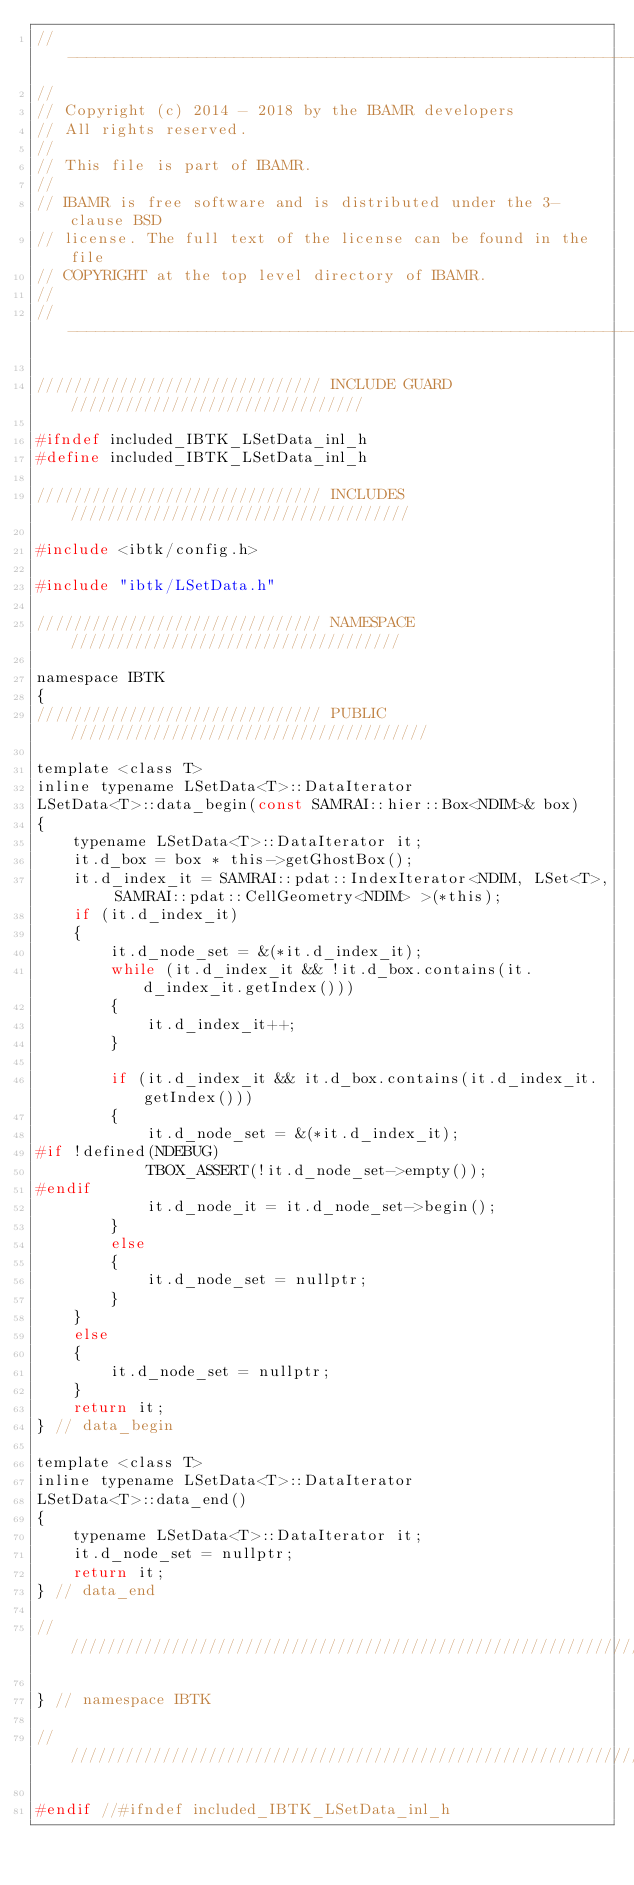<code> <loc_0><loc_0><loc_500><loc_500><_C_>// ---------------------------------------------------------------------
//
// Copyright (c) 2014 - 2018 by the IBAMR developers
// All rights reserved.
//
// This file is part of IBAMR.
//
// IBAMR is free software and is distributed under the 3-clause BSD
// license. The full text of the license can be found in the file
// COPYRIGHT at the top level directory of IBAMR.
//
// ---------------------------------------------------------------------

/////////////////////////////// INCLUDE GUARD ////////////////////////////////

#ifndef included_IBTK_LSetData_inl_h
#define included_IBTK_LSetData_inl_h

/////////////////////////////// INCLUDES /////////////////////////////////////

#include <ibtk/config.h>

#include "ibtk/LSetData.h"

/////////////////////////////// NAMESPACE ////////////////////////////////////

namespace IBTK
{
/////////////////////////////// PUBLIC ///////////////////////////////////////

template <class T>
inline typename LSetData<T>::DataIterator
LSetData<T>::data_begin(const SAMRAI::hier::Box<NDIM>& box)
{
    typename LSetData<T>::DataIterator it;
    it.d_box = box * this->getGhostBox();
    it.d_index_it = SAMRAI::pdat::IndexIterator<NDIM, LSet<T>, SAMRAI::pdat::CellGeometry<NDIM> >(*this);
    if (it.d_index_it)
    {
        it.d_node_set = &(*it.d_index_it);
        while (it.d_index_it && !it.d_box.contains(it.d_index_it.getIndex()))
        {
            it.d_index_it++;
        }

        if (it.d_index_it && it.d_box.contains(it.d_index_it.getIndex()))
        {
            it.d_node_set = &(*it.d_index_it);
#if !defined(NDEBUG)
            TBOX_ASSERT(!it.d_node_set->empty());
#endif
            it.d_node_it = it.d_node_set->begin();
        }
        else
        {
            it.d_node_set = nullptr;
        }
    }
    else
    {
        it.d_node_set = nullptr;
    }
    return it;
} // data_begin

template <class T>
inline typename LSetData<T>::DataIterator
LSetData<T>::data_end()
{
    typename LSetData<T>::DataIterator it;
    it.d_node_set = nullptr;
    return it;
} // data_end

//////////////////////////////////////////////////////////////////////////////

} // namespace IBTK

//////////////////////////////////////////////////////////////////////////////

#endif //#ifndef included_IBTK_LSetData_inl_h
</code> 